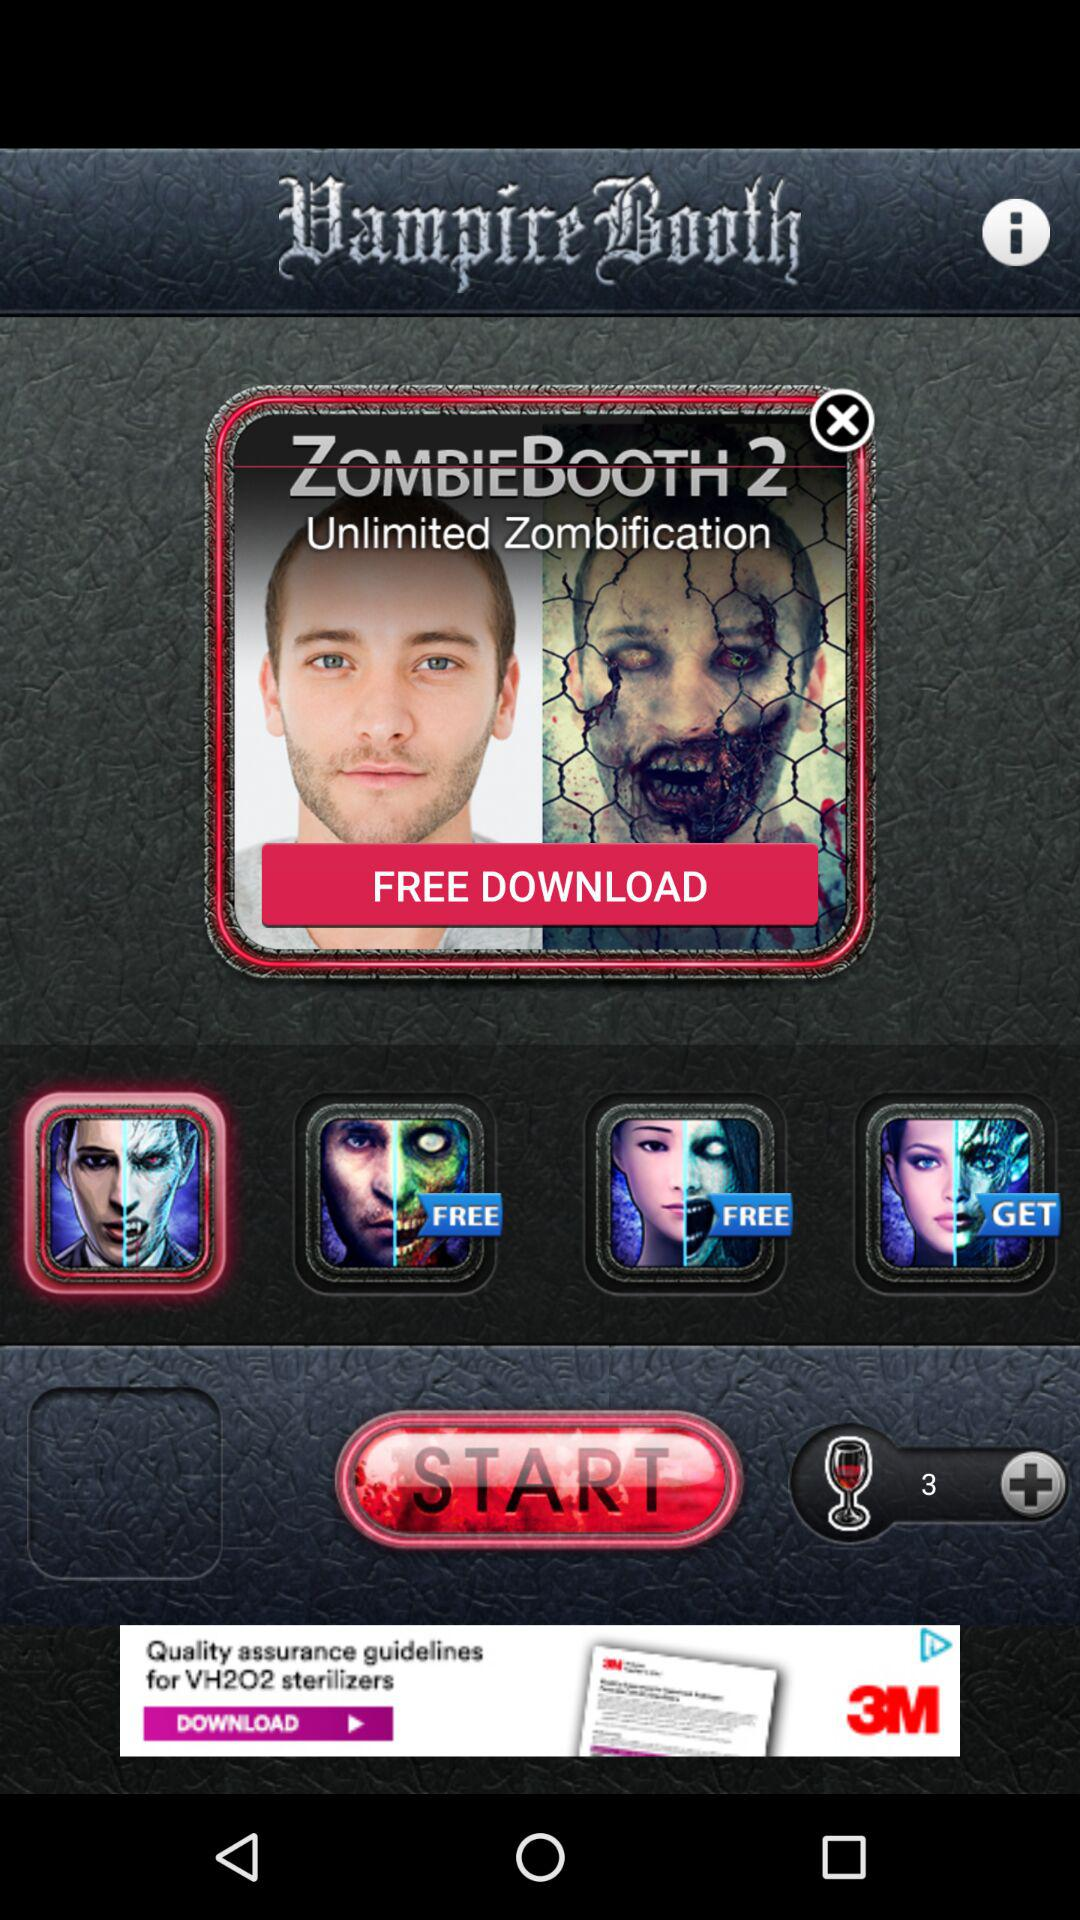What is the application name? The application names are "Vampire Booth" and "ZOMBIEBOOTH 2". 